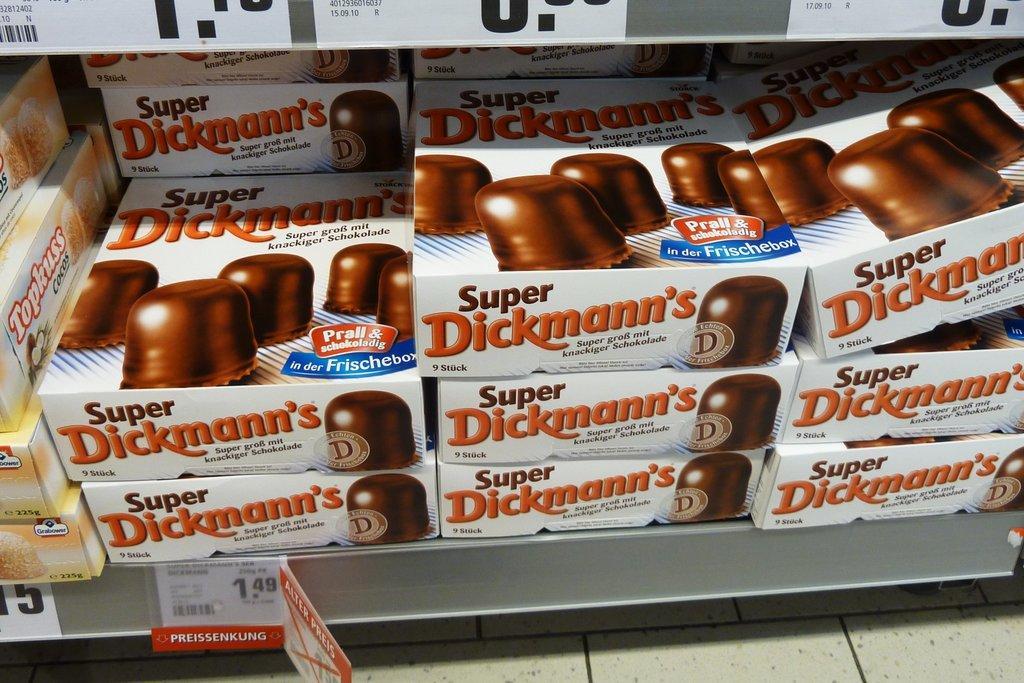In one or two sentences, can you explain what this image depicts? In this picture I can see number of boxes on a rack and on the boxes I can see words written, I can also see the pictures of food. On the bottom left side of this picture I can see the price tags and I can see the floor. On the top of this picture, I can see few more price tags. 